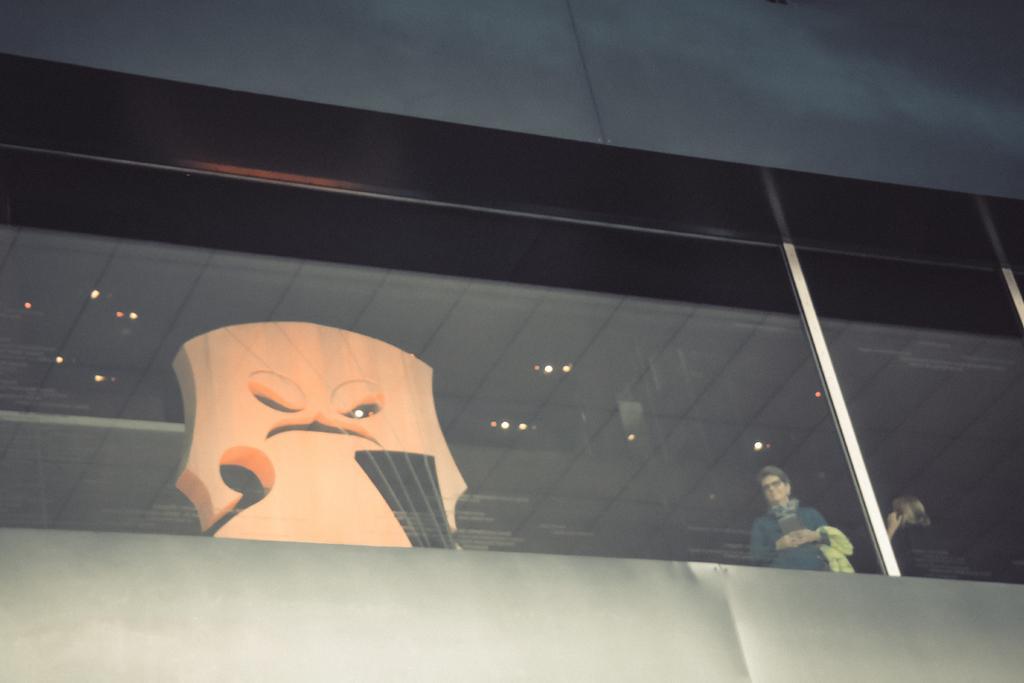Describe this image in one or two sentences. In this image there is a building and we can see a decor and people through the glass. 